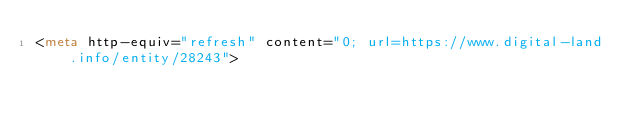Convert code to text. <code><loc_0><loc_0><loc_500><loc_500><_HTML_><meta http-equiv="refresh" content="0; url=https://www.digital-land.info/entity/28243"></code> 